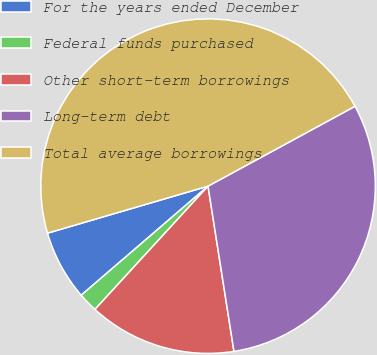Convert chart to OTSL. <chart><loc_0><loc_0><loc_500><loc_500><pie_chart><fcel>For the years ended December<fcel>Federal funds purchased<fcel>Other short-term borrowings<fcel>Long-term debt<fcel>Total average borrowings<nl><fcel>6.77%<fcel>1.88%<fcel>14.29%<fcel>30.44%<fcel>46.61%<nl></chart> 